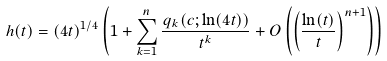Convert formula to latex. <formula><loc_0><loc_0><loc_500><loc_500>h ( t ) = ( 4 t ) ^ { 1 / 4 } \left ( 1 + \sum ^ { n } _ { k = 1 } \frac { q _ { k } ( c ; \ln ( 4 t ) ) } { t ^ { k } } + O \left ( \left ( \frac { \ln ( t ) } { t } \right ) ^ { n + 1 } \right ) \right )</formula> 